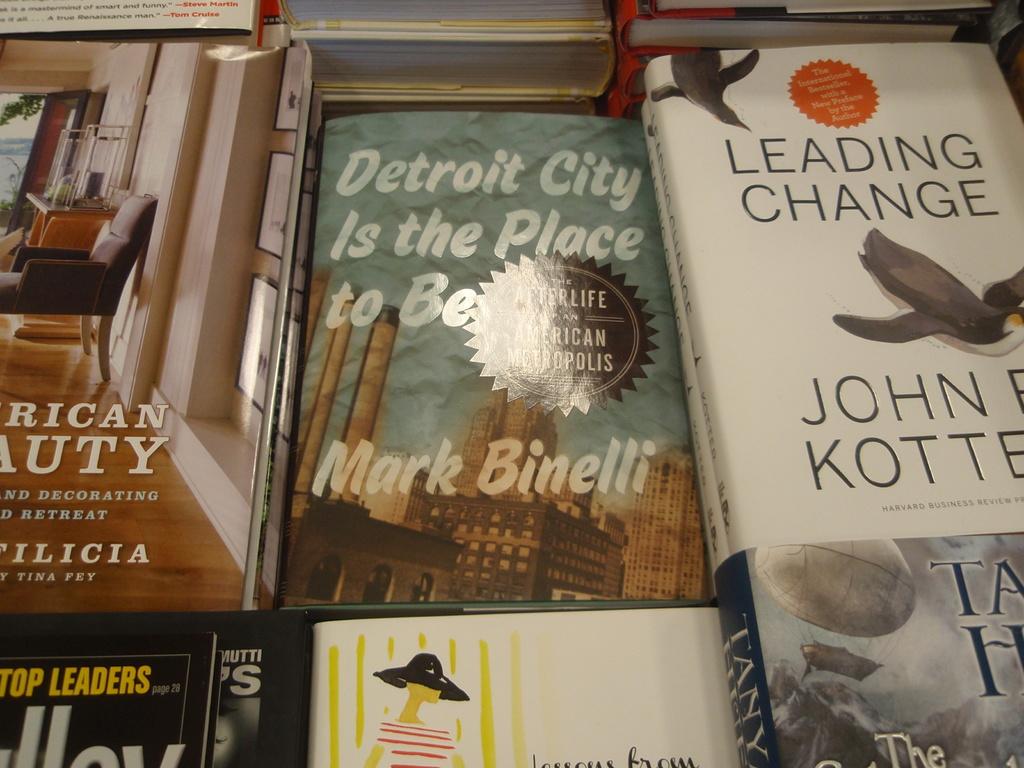Who wrote 'detroit city is the place to be'?
Offer a terse response. Mark binelli. What is the title of the white book?
Your response must be concise. Leading change. 